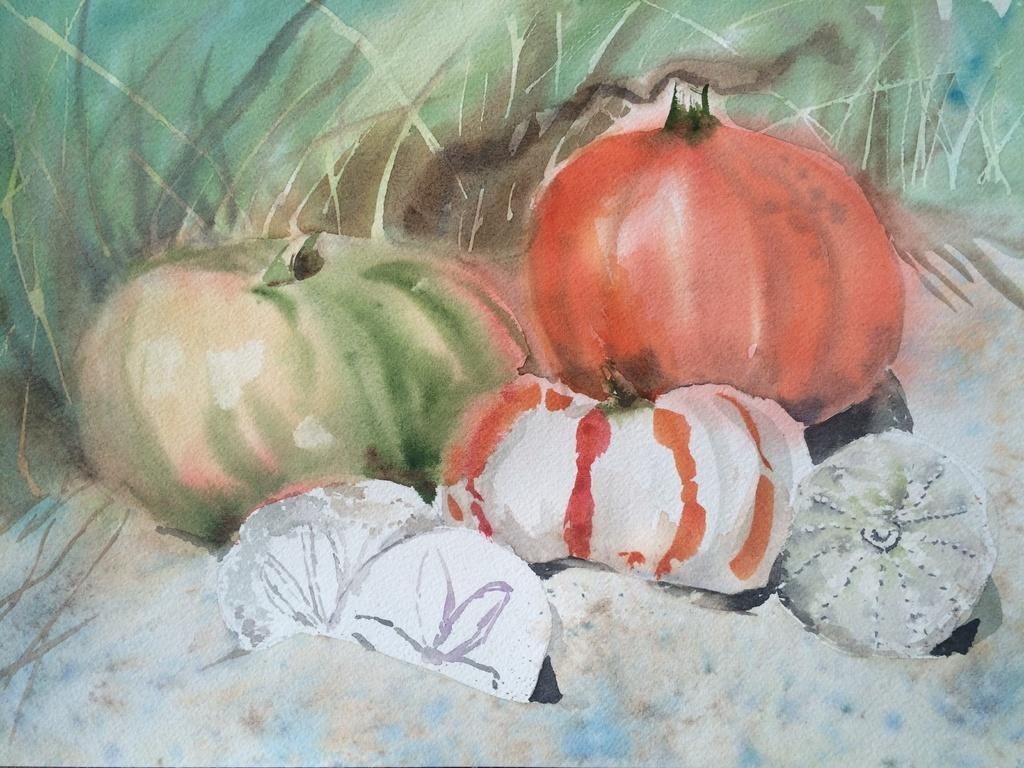What is the main subject of the image? There is a painting in the image. How many visitors can be seen in the image while the teacher is on a trip? There is no information about visitors or a trip in the image, as it only features a painting. 